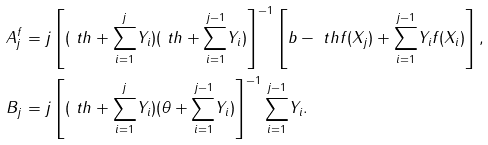Convert formula to latex. <formula><loc_0><loc_0><loc_500><loc_500>A ^ { f } _ { j } & = j \left [ ( \ t h + { \sum _ { i = 1 } ^ { j } } Y _ { i } ) ( \ t h + { \sum _ { i = 1 } ^ { j - 1 } } Y _ { i } ) \right ] ^ { - 1 } \left [ b - \ t h f ( X _ { j } ) + { \sum _ { i = 1 } ^ { j - 1 } } Y _ { i } f ( X _ { i } ) \right ] , \\ B _ { j } & = j \left [ ( \ t h + { \sum _ { i = 1 } ^ { j } } Y _ { i } ) ( \theta + { \sum _ { i = 1 } ^ { j - 1 } } Y _ { i } ) \right ] ^ { - 1 } { \sum _ { i = 1 } ^ { j - 1 } } Y _ { i } .</formula> 